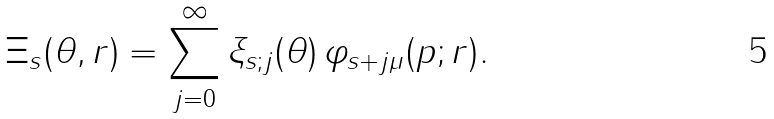Convert formula to latex. <formula><loc_0><loc_0><loc_500><loc_500>\Xi _ { s } ( \theta , r ) = \sum _ { j = 0 } ^ { \infty } \xi _ { s ; j } ( \theta ) \, \varphi _ { s + j \mu } ( p ; r ) .</formula> 